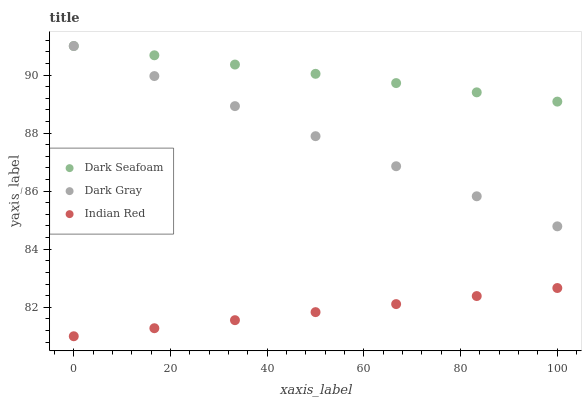Does Indian Red have the minimum area under the curve?
Answer yes or no. Yes. Does Dark Seafoam have the maximum area under the curve?
Answer yes or no. Yes. Does Dark Seafoam have the minimum area under the curve?
Answer yes or no. No. Does Indian Red have the maximum area under the curve?
Answer yes or no. No. Is Indian Red the smoothest?
Answer yes or no. Yes. Is Dark Gray the roughest?
Answer yes or no. Yes. Is Dark Seafoam the smoothest?
Answer yes or no. No. Is Dark Seafoam the roughest?
Answer yes or no. No. Does Indian Red have the lowest value?
Answer yes or no. Yes. Does Dark Seafoam have the lowest value?
Answer yes or no. No. Does Dark Seafoam have the highest value?
Answer yes or no. Yes. Does Indian Red have the highest value?
Answer yes or no. No. Is Indian Red less than Dark Seafoam?
Answer yes or no. Yes. Is Dark Seafoam greater than Indian Red?
Answer yes or no. Yes. Does Dark Gray intersect Dark Seafoam?
Answer yes or no. Yes. Is Dark Gray less than Dark Seafoam?
Answer yes or no. No. Is Dark Gray greater than Dark Seafoam?
Answer yes or no. No. Does Indian Red intersect Dark Seafoam?
Answer yes or no. No. 